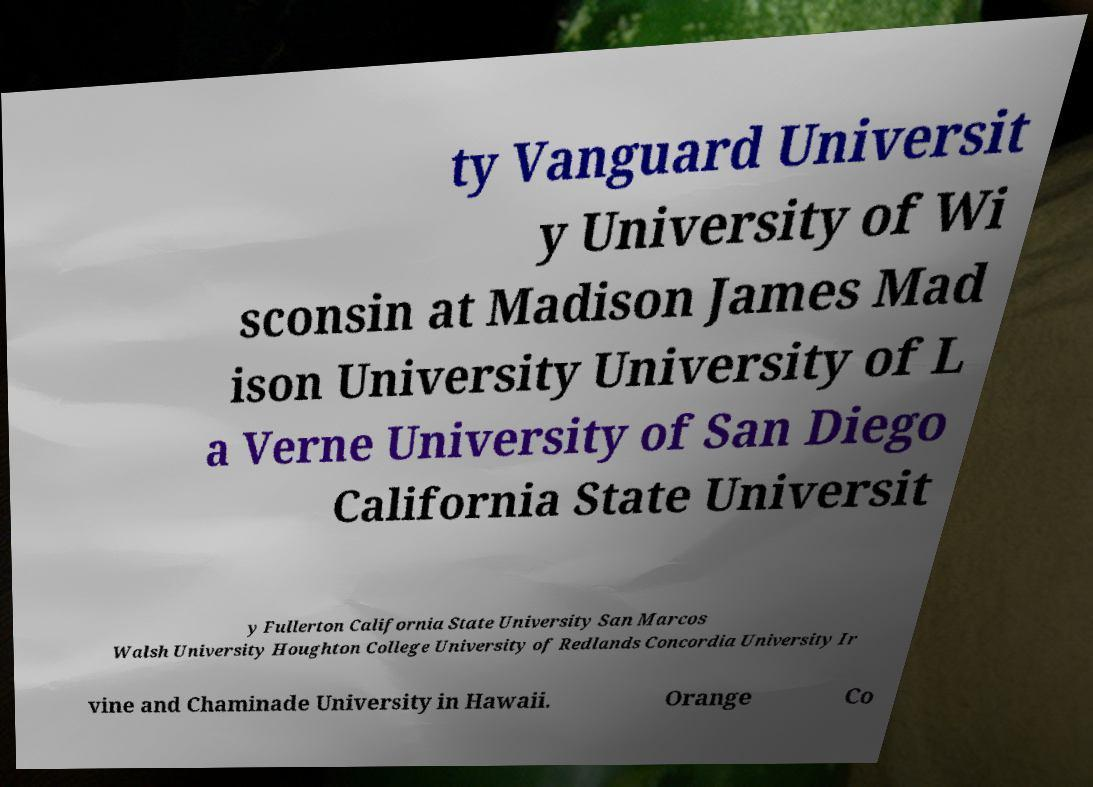Please identify and transcribe the text found in this image. ty Vanguard Universit y University of Wi sconsin at Madison James Mad ison University University of L a Verne University of San Diego California State Universit y Fullerton California State University San Marcos Walsh University Houghton College University of Redlands Concordia University Ir vine and Chaminade University in Hawaii. Orange Co 